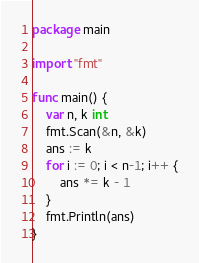<code> <loc_0><loc_0><loc_500><loc_500><_Go_>package main

import "fmt"

func main() {
	var n, k int
	fmt.Scan(&n, &k)
	ans := k
	for i := 0; i < n-1; i++ {
		ans *= k - 1
	}
	fmt.Println(ans)
}
</code> 